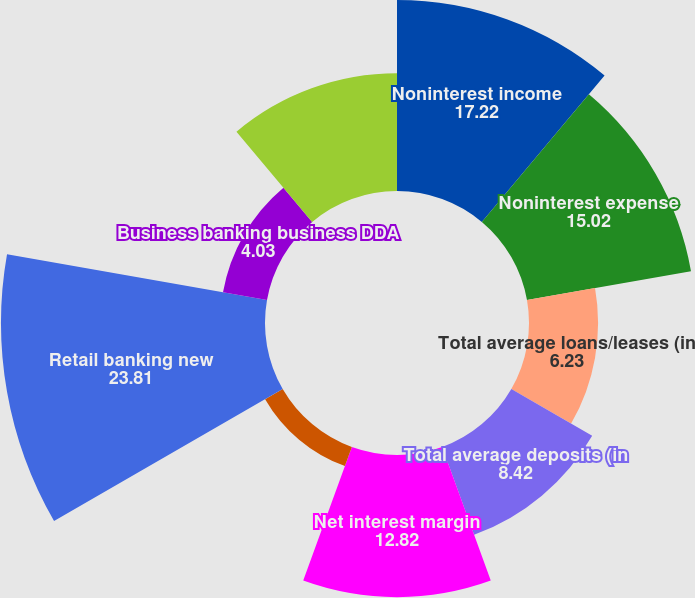Convert chart. <chart><loc_0><loc_0><loc_500><loc_500><pie_chart><fcel>Noninterest income<fcel>Noninterest expense<fcel>Total average loans/leases (in<fcel>Total average deposits (in<fcel>Net interest margin<fcel>Retail banking DDAhouseholds<fcel>Retail banking new<fcel>Business banking business DDA<fcel>Business banking new<nl><fcel>17.22%<fcel>15.02%<fcel>6.23%<fcel>8.42%<fcel>12.82%<fcel>1.83%<fcel>23.81%<fcel>4.03%<fcel>10.62%<nl></chart> 